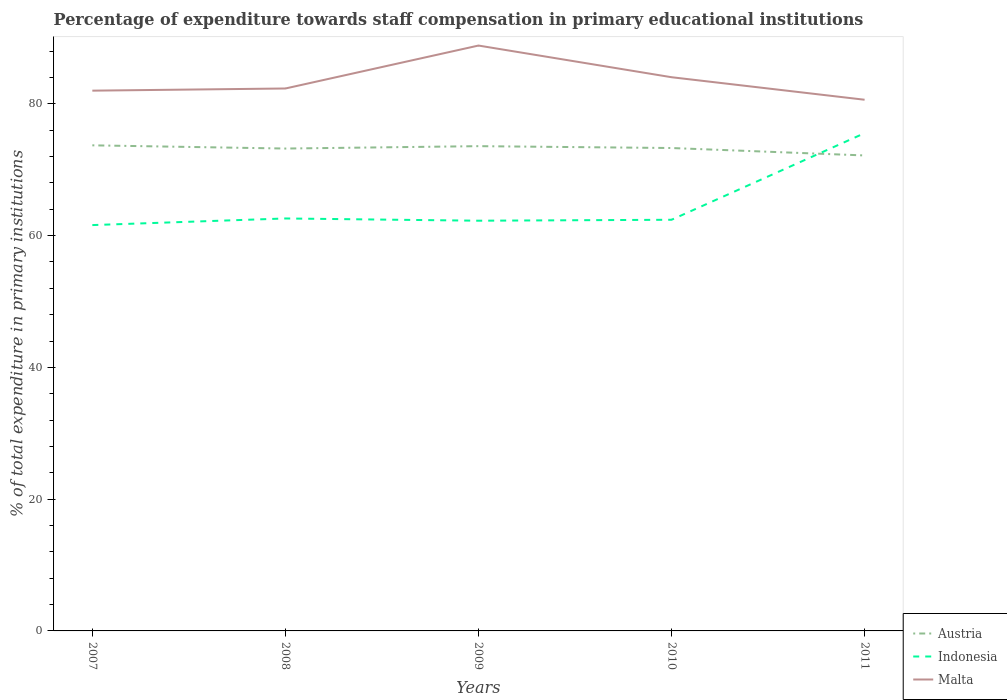Across all years, what is the maximum percentage of expenditure towards staff compensation in Indonesia?
Offer a very short reply. 61.6. In which year was the percentage of expenditure towards staff compensation in Indonesia maximum?
Your answer should be compact. 2007. What is the total percentage of expenditure towards staff compensation in Malta in the graph?
Offer a terse response. -6.85. What is the difference between the highest and the second highest percentage of expenditure towards staff compensation in Indonesia?
Give a very brief answer. 13.95. Is the percentage of expenditure towards staff compensation in Malta strictly greater than the percentage of expenditure towards staff compensation in Austria over the years?
Offer a very short reply. No. How many lines are there?
Your response must be concise. 3. What is the difference between two consecutive major ticks on the Y-axis?
Provide a succinct answer. 20. Does the graph contain any zero values?
Provide a short and direct response. No. Where does the legend appear in the graph?
Your answer should be compact. Bottom right. What is the title of the graph?
Ensure brevity in your answer.  Percentage of expenditure towards staff compensation in primary educational institutions. Does "Chile" appear as one of the legend labels in the graph?
Make the answer very short. No. What is the label or title of the Y-axis?
Your answer should be very brief. % of total expenditure in primary institutions. What is the % of total expenditure in primary institutions in Austria in 2007?
Make the answer very short. 73.71. What is the % of total expenditure in primary institutions in Indonesia in 2007?
Offer a very short reply. 61.6. What is the % of total expenditure in primary institutions of Malta in 2007?
Ensure brevity in your answer.  82.01. What is the % of total expenditure in primary institutions of Austria in 2008?
Your answer should be very brief. 73.22. What is the % of total expenditure in primary institutions of Indonesia in 2008?
Offer a very short reply. 62.61. What is the % of total expenditure in primary institutions of Malta in 2008?
Make the answer very short. 82.34. What is the % of total expenditure in primary institutions of Austria in 2009?
Offer a very short reply. 73.58. What is the % of total expenditure in primary institutions of Indonesia in 2009?
Your answer should be very brief. 62.27. What is the % of total expenditure in primary institutions in Malta in 2009?
Your answer should be compact. 88.85. What is the % of total expenditure in primary institutions in Austria in 2010?
Offer a very short reply. 73.3. What is the % of total expenditure in primary institutions in Indonesia in 2010?
Provide a succinct answer. 62.41. What is the % of total expenditure in primary institutions in Malta in 2010?
Provide a short and direct response. 84.05. What is the % of total expenditure in primary institutions in Austria in 2011?
Offer a very short reply. 72.17. What is the % of total expenditure in primary institutions of Indonesia in 2011?
Provide a short and direct response. 75.56. What is the % of total expenditure in primary institutions in Malta in 2011?
Give a very brief answer. 80.63. Across all years, what is the maximum % of total expenditure in primary institutions of Austria?
Your response must be concise. 73.71. Across all years, what is the maximum % of total expenditure in primary institutions of Indonesia?
Offer a terse response. 75.56. Across all years, what is the maximum % of total expenditure in primary institutions of Malta?
Your answer should be very brief. 88.85. Across all years, what is the minimum % of total expenditure in primary institutions in Austria?
Offer a terse response. 72.17. Across all years, what is the minimum % of total expenditure in primary institutions in Indonesia?
Provide a succinct answer. 61.6. Across all years, what is the minimum % of total expenditure in primary institutions in Malta?
Keep it short and to the point. 80.63. What is the total % of total expenditure in primary institutions in Austria in the graph?
Offer a terse response. 365.98. What is the total % of total expenditure in primary institutions in Indonesia in the graph?
Your answer should be compact. 324.44. What is the total % of total expenditure in primary institutions in Malta in the graph?
Provide a succinct answer. 417.87. What is the difference between the % of total expenditure in primary institutions in Austria in 2007 and that in 2008?
Provide a short and direct response. 0.49. What is the difference between the % of total expenditure in primary institutions of Indonesia in 2007 and that in 2008?
Keep it short and to the point. -1.01. What is the difference between the % of total expenditure in primary institutions in Malta in 2007 and that in 2008?
Give a very brief answer. -0.33. What is the difference between the % of total expenditure in primary institutions in Austria in 2007 and that in 2009?
Give a very brief answer. 0.13. What is the difference between the % of total expenditure in primary institutions in Indonesia in 2007 and that in 2009?
Keep it short and to the point. -0.66. What is the difference between the % of total expenditure in primary institutions of Malta in 2007 and that in 2009?
Offer a very short reply. -6.85. What is the difference between the % of total expenditure in primary institutions in Austria in 2007 and that in 2010?
Your answer should be compact. 0.41. What is the difference between the % of total expenditure in primary institutions in Indonesia in 2007 and that in 2010?
Make the answer very short. -0.81. What is the difference between the % of total expenditure in primary institutions of Malta in 2007 and that in 2010?
Give a very brief answer. -2.04. What is the difference between the % of total expenditure in primary institutions in Austria in 2007 and that in 2011?
Your response must be concise. 1.54. What is the difference between the % of total expenditure in primary institutions in Indonesia in 2007 and that in 2011?
Your answer should be compact. -13.95. What is the difference between the % of total expenditure in primary institutions in Malta in 2007 and that in 2011?
Offer a very short reply. 1.38. What is the difference between the % of total expenditure in primary institutions of Austria in 2008 and that in 2009?
Provide a succinct answer. -0.36. What is the difference between the % of total expenditure in primary institutions in Indonesia in 2008 and that in 2009?
Your response must be concise. 0.34. What is the difference between the % of total expenditure in primary institutions of Malta in 2008 and that in 2009?
Ensure brevity in your answer.  -6.52. What is the difference between the % of total expenditure in primary institutions of Austria in 2008 and that in 2010?
Provide a short and direct response. -0.08. What is the difference between the % of total expenditure in primary institutions in Indonesia in 2008 and that in 2010?
Ensure brevity in your answer.  0.2. What is the difference between the % of total expenditure in primary institutions of Malta in 2008 and that in 2010?
Provide a short and direct response. -1.71. What is the difference between the % of total expenditure in primary institutions of Austria in 2008 and that in 2011?
Keep it short and to the point. 1.05. What is the difference between the % of total expenditure in primary institutions in Indonesia in 2008 and that in 2011?
Offer a terse response. -12.95. What is the difference between the % of total expenditure in primary institutions in Malta in 2008 and that in 2011?
Your response must be concise. 1.71. What is the difference between the % of total expenditure in primary institutions in Austria in 2009 and that in 2010?
Keep it short and to the point. 0.28. What is the difference between the % of total expenditure in primary institutions of Indonesia in 2009 and that in 2010?
Keep it short and to the point. -0.14. What is the difference between the % of total expenditure in primary institutions in Malta in 2009 and that in 2010?
Your response must be concise. 4.81. What is the difference between the % of total expenditure in primary institutions in Austria in 2009 and that in 2011?
Offer a terse response. 1.41. What is the difference between the % of total expenditure in primary institutions in Indonesia in 2009 and that in 2011?
Your answer should be very brief. -13.29. What is the difference between the % of total expenditure in primary institutions in Malta in 2009 and that in 2011?
Make the answer very short. 8.23. What is the difference between the % of total expenditure in primary institutions of Austria in 2010 and that in 2011?
Your answer should be compact. 1.13. What is the difference between the % of total expenditure in primary institutions of Indonesia in 2010 and that in 2011?
Ensure brevity in your answer.  -13.15. What is the difference between the % of total expenditure in primary institutions in Malta in 2010 and that in 2011?
Your answer should be compact. 3.42. What is the difference between the % of total expenditure in primary institutions of Austria in 2007 and the % of total expenditure in primary institutions of Indonesia in 2008?
Keep it short and to the point. 11.1. What is the difference between the % of total expenditure in primary institutions of Austria in 2007 and the % of total expenditure in primary institutions of Malta in 2008?
Ensure brevity in your answer.  -8.63. What is the difference between the % of total expenditure in primary institutions of Indonesia in 2007 and the % of total expenditure in primary institutions of Malta in 2008?
Provide a succinct answer. -20.73. What is the difference between the % of total expenditure in primary institutions in Austria in 2007 and the % of total expenditure in primary institutions in Indonesia in 2009?
Your answer should be very brief. 11.44. What is the difference between the % of total expenditure in primary institutions in Austria in 2007 and the % of total expenditure in primary institutions in Malta in 2009?
Offer a terse response. -15.15. What is the difference between the % of total expenditure in primary institutions in Indonesia in 2007 and the % of total expenditure in primary institutions in Malta in 2009?
Your response must be concise. -27.25. What is the difference between the % of total expenditure in primary institutions in Austria in 2007 and the % of total expenditure in primary institutions in Indonesia in 2010?
Give a very brief answer. 11.3. What is the difference between the % of total expenditure in primary institutions in Austria in 2007 and the % of total expenditure in primary institutions in Malta in 2010?
Provide a short and direct response. -10.34. What is the difference between the % of total expenditure in primary institutions of Indonesia in 2007 and the % of total expenditure in primary institutions of Malta in 2010?
Make the answer very short. -22.44. What is the difference between the % of total expenditure in primary institutions in Austria in 2007 and the % of total expenditure in primary institutions in Indonesia in 2011?
Offer a very short reply. -1.85. What is the difference between the % of total expenditure in primary institutions in Austria in 2007 and the % of total expenditure in primary institutions in Malta in 2011?
Your answer should be very brief. -6.92. What is the difference between the % of total expenditure in primary institutions in Indonesia in 2007 and the % of total expenditure in primary institutions in Malta in 2011?
Offer a terse response. -19.03. What is the difference between the % of total expenditure in primary institutions in Austria in 2008 and the % of total expenditure in primary institutions in Indonesia in 2009?
Make the answer very short. 10.95. What is the difference between the % of total expenditure in primary institutions of Austria in 2008 and the % of total expenditure in primary institutions of Malta in 2009?
Offer a very short reply. -15.63. What is the difference between the % of total expenditure in primary institutions in Indonesia in 2008 and the % of total expenditure in primary institutions in Malta in 2009?
Offer a terse response. -26.25. What is the difference between the % of total expenditure in primary institutions of Austria in 2008 and the % of total expenditure in primary institutions of Indonesia in 2010?
Your response must be concise. 10.81. What is the difference between the % of total expenditure in primary institutions in Austria in 2008 and the % of total expenditure in primary institutions in Malta in 2010?
Provide a succinct answer. -10.83. What is the difference between the % of total expenditure in primary institutions in Indonesia in 2008 and the % of total expenditure in primary institutions in Malta in 2010?
Provide a succinct answer. -21.44. What is the difference between the % of total expenditure in primary institutions of Austria in 2008 and the % of total expenditure in primary institutions of Indonesia in 2011?
Your answer should be very brief. -2.34. What is the difference between the % of total expenditure in primary institutions of Austria in 2008 and the % of total expenditure in primary institutions of Malta in 2011?
Make the answer very short. -7.41. What is the difference between the % of total expenditure in primary institutions in Indonesia in 2008 and the % of total expenditure in primary institutions in Malta in 2011?
Offer a terse response. -18.02. What is the difference between the % of total expenditure in primary institutions of Austria in 2009 and the % of total expenditure in primary institutions of Indonesia in 2010?
Provide a short and direct response. 11.17. What is the difference between the % of total expenditure in primary institutions of Austria in 2009 and the % of total expenditure in primary institutions of Malta in 2010?
Provide a succinct answer. -10.46. What is the difference between the % of total expenditure in primary institutions in Indonesia in 2009 and the % of total expenditure in primary institutions in Malta in 2010?
Provide a short and direct response. -21.78. What is the difference between the % of total expenditure in primary institutions in Austria in 2009 and the % of total expenditure in primary institutions in Indonesia in 2011?
Provide a succinct answer. -1.97. What is the difference between the % of total expenditure in primary institutions of Austria in 2009 and the % of total expenditure in primary institutions of Malta in 2011?
Your answer should be compact. -7.04. What is the difference between the % of total expenditure in primary institutions of Indonesia in 2009 and the % of total expenditure in primary institutions of Malta in 2011?
Your response must be concise. -18.36. What is the difference between the % of total expenditure in primary institutions of Austria in 2010 and the % of total expenditure in primary institutions of Indonesia in 2011?
Offer a very short reply. -2.26. What is the difference between the % of total expenditure in primary institutions in Austria in 2010 and the % of total expenditure in primary institutions in Malta in 2011?
Offer a very short reply. -7.33. What is the difference between the % of total expenditure in primary institutions in Indonesia in 2010 and the % of total expenditure in primary institutions in Malta in 2011?
Your answer should be compact. -18.22. What is the average % of total expenditure in primary institutions of Austria per year?
Ensure brevity in your answer.  73.2. What is the average % of total expenditure in primary institutions of Indonesia per year?
Your response must be concise. 64.89. What is the average % of total expenditure in primary institutions in Malta per year?
Offer a very short reply. 83.57. In the year 2007, what is the difference between the % of total expenditure in primary institutions of Austria and % of total expenditure in primary institutions of Indonesia?
Give a very brief answer. 12.11. In the year 2007, what is the difference between the % of total expenditure in primary institutions of Austria and % of total expenditure in primary institutions of Malta?
Your answer should be compact. -8.3. In the year 2007, what is the difference between the % of total expenditure in primary institutions of Indonesia and % of total expenditure in primary institutions of Malta?
Give a very brief answer. -20.4. In the year 2008, what is the difference between the % of total expenditure in primary institutions of Austria and % of total expenditure in primary institutions of Indonesia?
Give a very brief answer. 10.61. In the year 2008, what is the difference between the % of total expenditure in primary institutions of Austria and % of total expenditure in primary institutions of Malta?
Make the answer very short. -9.12. In the year 2008, what is the difference between the % of total expenditure in primary institutions of Indonesia and % of total expenditure in primary institutions of Malta?
Offer a terse response. -19.73. In the year 2009, what is the difference between the % of total expenditure in primary institutions of Austria and % of total expenditure in primary institutions of Indonesia?
Offer a terse response. 11.32. In the year 2009, what is the difference between the % of total expenditure in primary institutions of Austria and % of total expenditure in primary institutions of Malta?
Offer a very short reply. -15.27. In the year 2009, what is the difference between the % of total expenditure in primary institutions in Indonesia and % of total expenditure in primary institutions in Malta?
Your answer should be very brief. -26.59. In the year 2010, what is the difference between the % of total expenditure in primary institutions in Austria and % of total expenditure in primary institutions in Indonesia?
Offer a terse response. 10.89. In the year 2010, what is the difference between the % of total expenditure in primary institutions in Austria and % of total expenditure in primary institutions in Malta?
Provide a succinct answer. -10.75. In the year 2010, what is the difference between the % of total expenditure in primary institutions of Indonesia and % of total expenditure in primary institutions of Malta?
Give a very brief answer. -21.64. In the year 2011, what is the difference between the % of total expenditure in primary institutions of Austria and % of total expenditure in primary institutions of Indonesia?
Offer a very short reply. -3.38. In the year 2011, what is the difference between the % of total expenditure in primary institutions in Austria and % of total expenditure in primary institutions in Malta?
Your response must be concise. -8.46. In the year 2011, what is the difference between the % of total expenditure in primary institutions of Indonesia and % of total expenditure in primary institutions of Malta?
Ensure brevity in your answer.  -5.07. What is the ratio of the % of total expenditure in primary institutions of Indonesia in 2007 to that in 2008?
Offer a terse response. 0.98. What is the ratio of the % of total expenditure in primary institutions in Malta in 2007 to that in 2008?
Make the answer very short. 1. What is the ratio of the % of total expenditure in primary institutions of Indonesia in 2007 to that in 2009?
Ensure brevity in your answer.  0.99. What is the ratio of the % of total expenditure in primary institutions of Malta in 2007 to that in 2009?
Keep it short and to the point. 0.92. What is the ratio of the % of total expenditure in primary institutions of Austria in 2007 to that in 2010?
Ensure brevity in your answer.  1.01. What is the ratio of the % of total expenditure in primary institutions of Indonesia in 2007 to that in 2010?
Your answer should be compact. 0.99. What is the ratio of the % of total expenditure in primary institutions in Malta in 2007 to that in 2010?
Keep it short and to the point. 0.98. What is the ratio of the % of total expenditure in primary institutions in Austria in 2007 to that in 2011?
Make the answer very short. 1.02. What is the ratio of the % of total expenditure in primary institutions of Indonesia in 2007 to that in 2011?
Offer a very short reply. 0.82. What is the ratio of the % of total expenditure in primary institutions of Malta in 2007 to that in 2011?
Offer a terse response. 1.02. What is the ratio of the % of total expenditure in primary institutions in Austria in 2008 to that in 2009?
Provide a short and direct response. 1. What is the ratio of the % of total expenditure in primary institutions of Indonesia in 2008 to that in 2009?
Keep it short and to the point. 1.01. What is the ratio of the % of total expenditure in primary institutions in Malta in 2008 to that in 2009?
Make the answer very short. 0.93. What is the ratio of the % of total expenditure in primary institutions in Austria in 2008 to that in 2010?
Offer a very short reply. 1. What is the ratio of the % of total expenditure in primary institutions of Indonesia in 2008 to that in 2010?
Your answer should be compact. 1. What is the ratio of the % of total expenditure in primary institutions in Malta in 2008 to that in 2010?
Your answer should be very brief. 0.98. What is the ratio of the % of total expenditure in primary institutions in Austria in 2008 to that in 2011?
Your answer should be compact. 1.01. What is the ratio of the % of total expenditure in primary institutions of Indonesia in 2008 to that in 2011?
Provide a short and direct response. 0.83. What is the ratio of the % of total expenditure in primary institutions of Malta in 2008 to that in 2011?
Keep it short and to the point. 1.02. What is the ratio of the % of total expenditure in primary institutions in Malta in 2009 to that in 2010?
Ensure brevity in your answer.  1.06. What is the ratio of the % of total expenditure in primary institutions of Austria in 2009 to that in 2011?
Your answer should be very brief. 1.02. What is the ratio of the % of total expenditure in primary institutions in Indonesia in 2009 to that in 2011?
Ensure brevity in your answer.  0.82. What is the ratio of the % of total expenditure in primary institutions of Malta in 2009 to that in 2011?
Keep it short and to the point. 1.1. What is the ratio of the % of total expenditure in primary institutions in Austria in 2010 to that in 2011?
Your response must be concise. 1.02. What is the ratio of the % of total expenditure in primary institutions of Indonesia in 2010 to that in 2011?
Your answer should be very brief. 0.83. What is the ratio of the % of total expenditure in primary institutions in Malta in 2010 to that in 2011?
Provide a short and direct response. 1.04. What is the difference between the highest and the second highest % of total expenditure in primary institutions of Austria?
Ensure brevity in your answer.  0.13. What is the difference between the highest and the second highest % of total expenditure in primary institutions of Indonesia?
Your response must be concise. 12.95. What is the difference between the highest and the second highest % of total expenditure in primary institutions of Malta?
Your response must be concise. 4.81. What is the difference between the highest and the lowest % of total expenditure in primary institutions of Austria?
Your answer should be compact. 1.54. What is the difference between the highest and the lowest % of total expenditure in primary institutions of Indonesia?
Make the answer very short. 13.95. What is the difference between the highest and the lowest % of total expenditure in primary institutions in Malta?
Give a very brief answer. 8.23. 